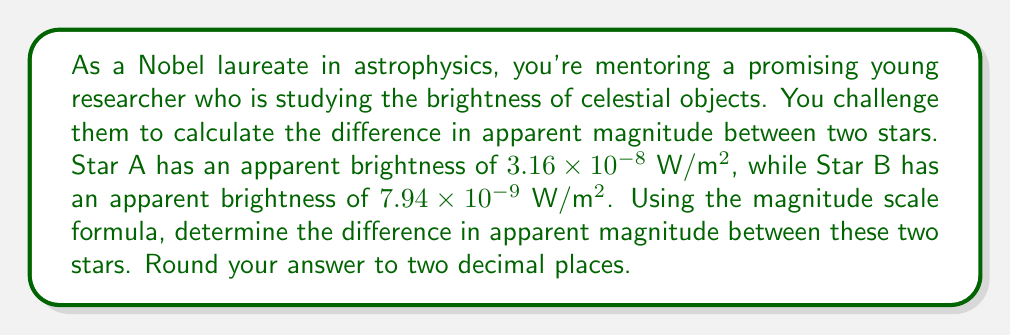Solve this math problem. Let's approach this step-by-step:

1) The magnitude scale formula is:

   $$m_1 - m_2 = -2.5 \log_{10}\left(\frac{I_1}{I_2}\right)$$

   where $m_1$ and $m_2$ are the magnitudes, and $I_1$ and $I_2$ are the intensities (or brightnesses) of the two objects.

2) In this case, let's assign:
   $I_1 = 3.16 \times 10^{-8}$ W/m² (Star A)
   $I_2 = 7.94 \times 10^{-9}$ W/m² (Star B)

3) We want to find $m_2 - m_1$, so we'll use:

   $$m_2 - m_1 = -2.5 \log_{10}\left(\frac{I_2}{I_1}\right)$$

4) Substituting the values:

   $$m_2 - m_1 = -2.5 \log_{10}\left(\frac{7.94 \times 10^{-9}}{3.16 \times 10^{-8}}\right)$$

5) Simplify inside the parentheses:

   $$m_2 - m_1 = -2.5 \log_{10}(0.2512658228)$$

6) Calculate the logarithm:

   $$m_2 - m_1 = -2.5 \times (-0.5997761)$$

7) Multiply:

   $$m_2 - m_1 = 1.4994402725$$

8) Rounding to two decimal places:

   $$m_2 - m_1 \approx 1.50$$

This means Star B appears 1.50 magnitudes fainter than Star A.
Answer: 1.50 